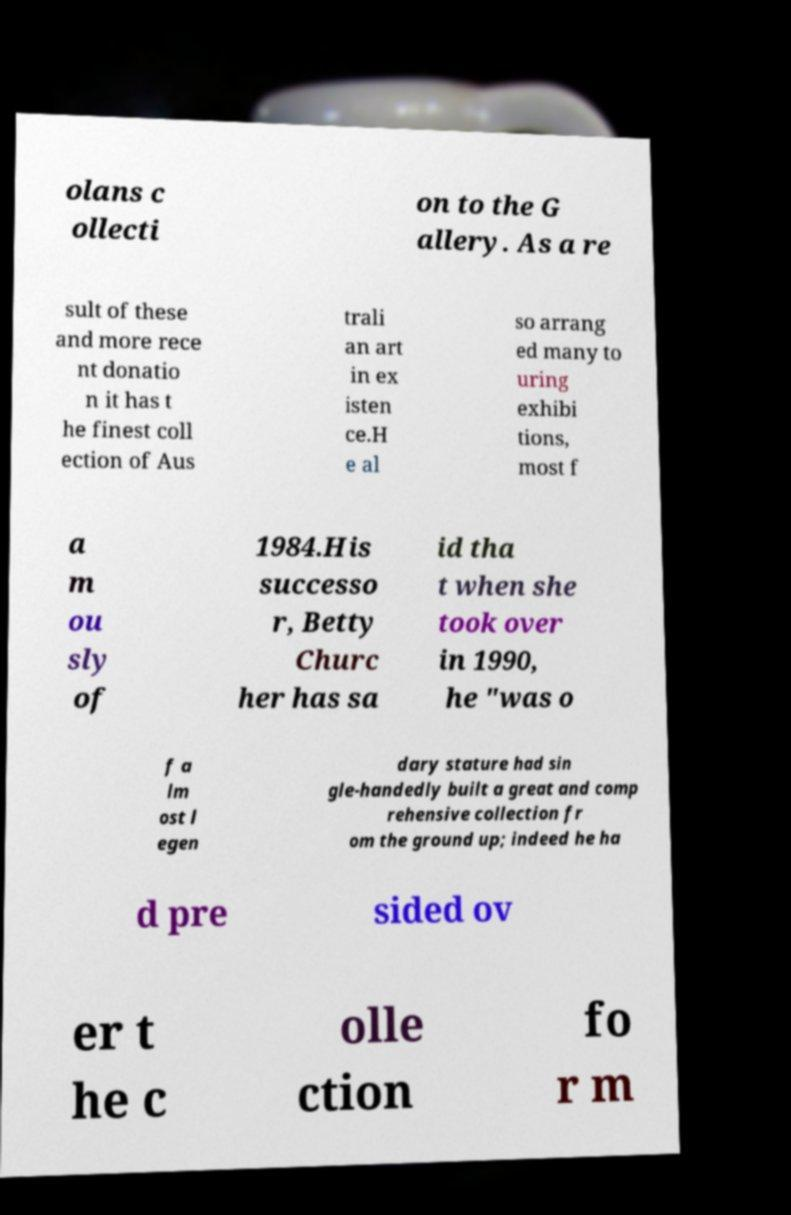Could you extract and type out the text from this image? olans c ollecti on to the G allery. As a re sult of these and more rece nt donatio n it has t he finest coll ection of Aus trali an art in ex isten ce.H e al so arrang ed many to uring exhibi tions, most f a m ou sly of 1984.His successo r, Betty Churc her has sa id tha t when she took over in 1990, he "was o f a lm ost l egen dary stature had sin gle-handedly built a great and comp rehensive collection fr om the ground up; indeed he ha d pre sided ov er t he c olle ction fo r m 